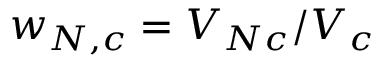Convert formula to latex. <formula><loc_0><loc_0><loc_500><loc_500>w _ { N , c } = V _ { N c } / V _ { c }</formula> 